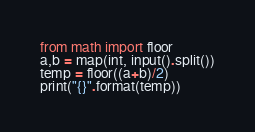<code> <loc_0><loc_0><loc_500><loc_500><_Python_>from math import floor
a,b = map(int, input().split())
temp = floor((a+b)/2)
print("{}".format(temp))</code> 